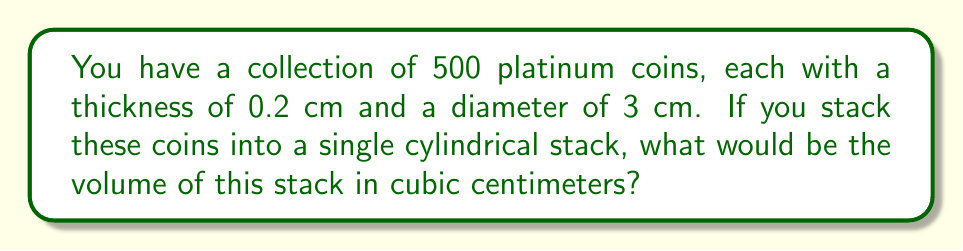Help me with this question. To solve this problem, we need to follow these steps:

1. Calculate the height of the stack:
   $h = 500 \text{ coins} \times 0.2 \text{ cm/coin} = 100 \text{ cm}$

2. Calculate the radius of the stack (half the diameter):
   $r = 3 \text{ cm} \div 2 = 1.5 \text{ cm}$

3. Use the formula for the volume of a cylinder:
   $$V = \pi r^2 h$$

4. Substitute the values:
   $$V = \pi \times (1.5 \text{ cm})^2 \times 100 \text{ cm}$$

5. Calculate:
   $$\begin{align}
   V &= \pi \times 2.25 \text{ cm}^2 \times 100 \text{ cm} \\
   &= 225\pi \text{ cm}^3 \\
   &\approx 706.86 \text{ cm}^3
   \end{align}$$

[asy]
import geometry;

// Draw cylinder
path3 p1=circle((0,0,0),1.5);
path3 p2=circle((0,0,10),1.5);
surface s1=surface(p1--p2--cycle);
draw(s1,paleblue+opacity(0.5));

// Draw base and top circles
draw(circle((0,0,0),1.5),blue);
draw(circle((0,0,10),1.5),blue);

// Draw height line
draw((1.5,0,0)--(1.5,0,10),red,Arrow3);

// Labels
label("r = 1.5 cm",(2,0,0),E);
label("h = 100 cm",(2,0,5),E);

[/asy]
Answer: $706.86 \text{ cm}^3$ 